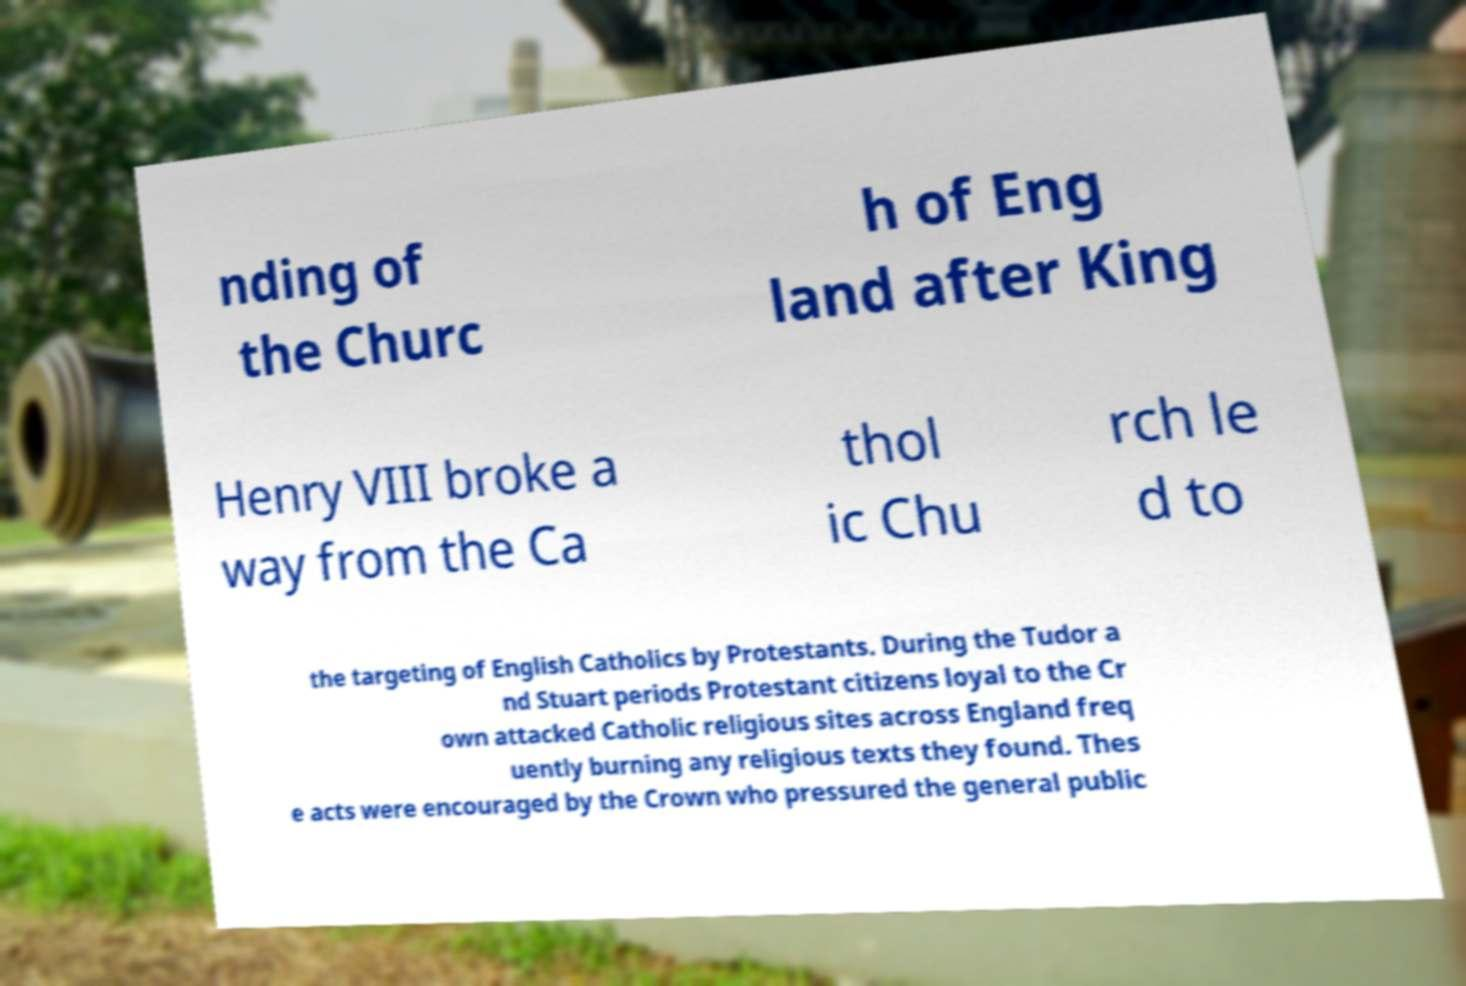Can you read and provide the text displayed in the image?This photo seems to have some interesting text. Can you extract and type it out for me? nding of the Churc h of Eng land after King Henry VIII broke a way from the Ca thol ic Chu rch le d to the targeting of English Catholics by Protestants. During the Tudor a nd Stuart periods Protestant citizens loyal to the Cr own attacked Catholic religious sites across England freq uently burning any religious texts they found. Thes e acts were encouraged by the Crown who pressured the general public 